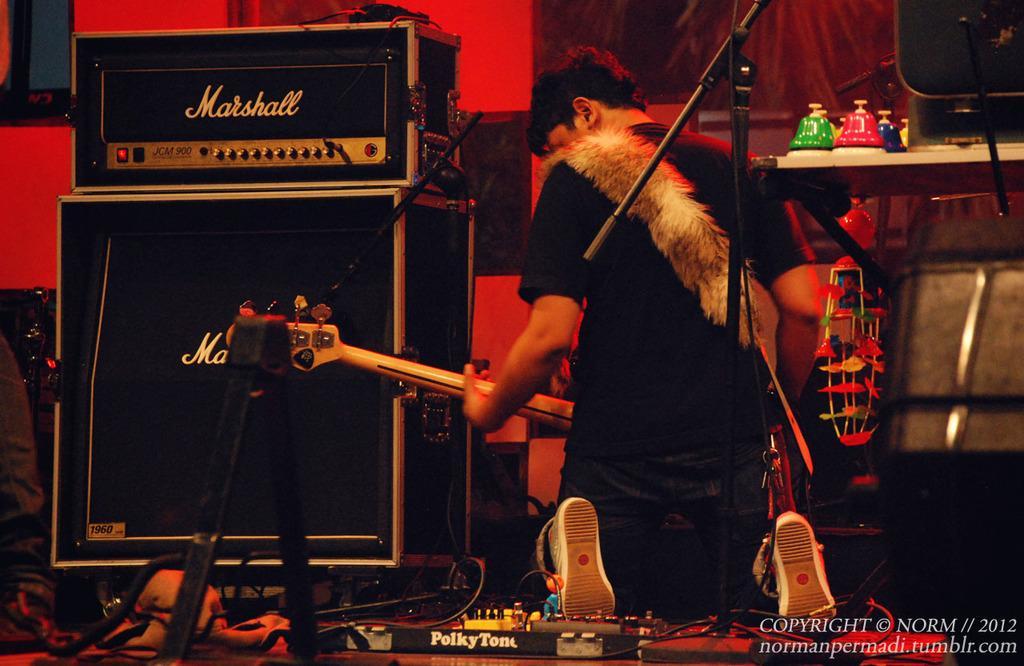In one or two sentences, can you explain what this image depicts? The person wearing black shirt is playing guitar and there are some boxes in front of him and the background is red in color. 